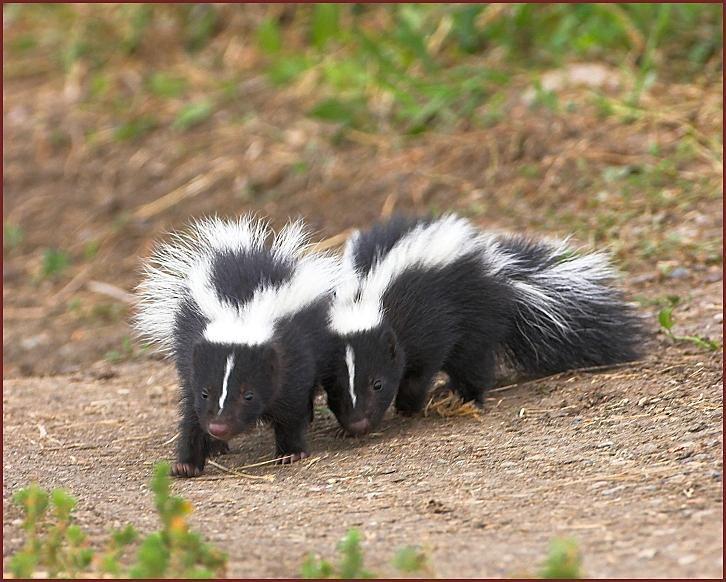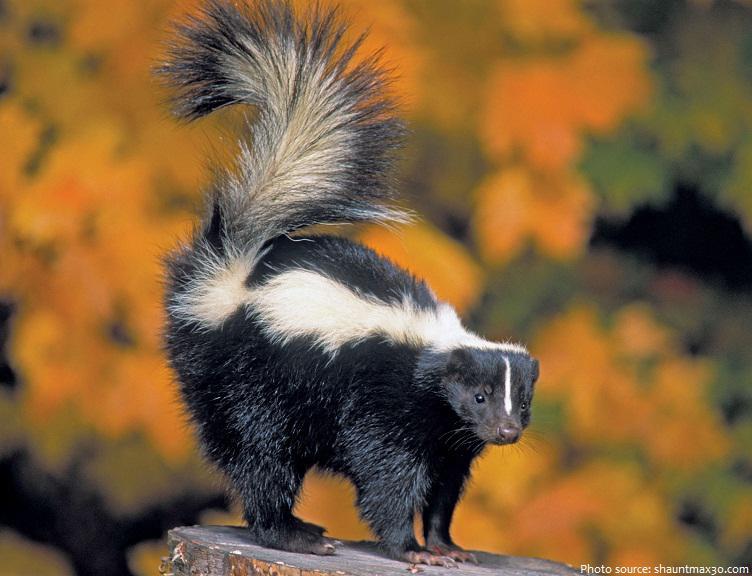The first image is the image on the left, the second image is the image on the right. Considering the images on both sides, is "One image contains a single skunk on all fours, and the other image features two side-by-side skunks with look-alike coloring and walking poses." valid? Answer yes or no. Yes. The first image is the image on the left, the second image is the image on the right. Given the left and right images, does the statement "There are three skunks." hold true? Answer yes or no. Yes. 